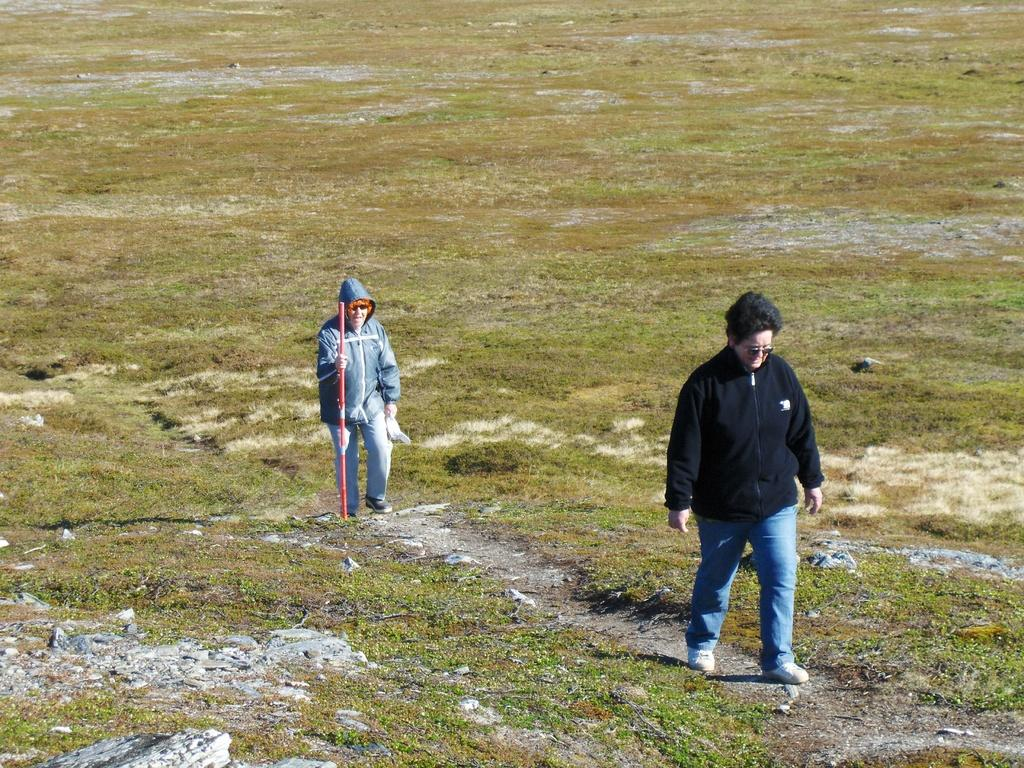What is the person on the right side of the image doing? The person on the right side of the image is walking. What is the person in the center of the image holding? The person in the center of the image is holding a stick. What type of terrain is visible at the bottom of the image? There is grass at the bottom of the image. What type of system is the person on the right side of the image using to walk? The person on the right side of the image is not using any system to walk; they are walking naturally. Can you describe the intricate details of the stick being held by the person in the center of the image? There is no mention of intricate details on the stick in the provided facts, so we cannot describe them. 